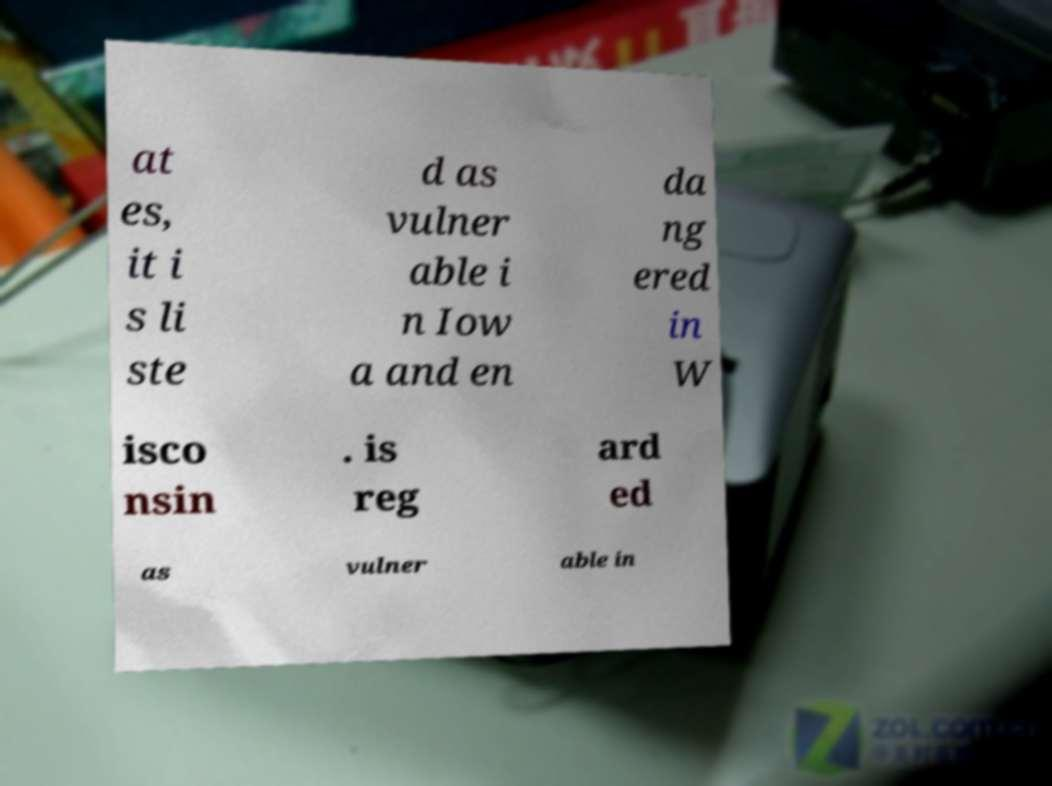Please identify and transcribe the text found in this image. at es, it i s li ste d as vulner able i n Iow a and en da ng ered in W isco nsin . is reg ard ed as vulner able in 